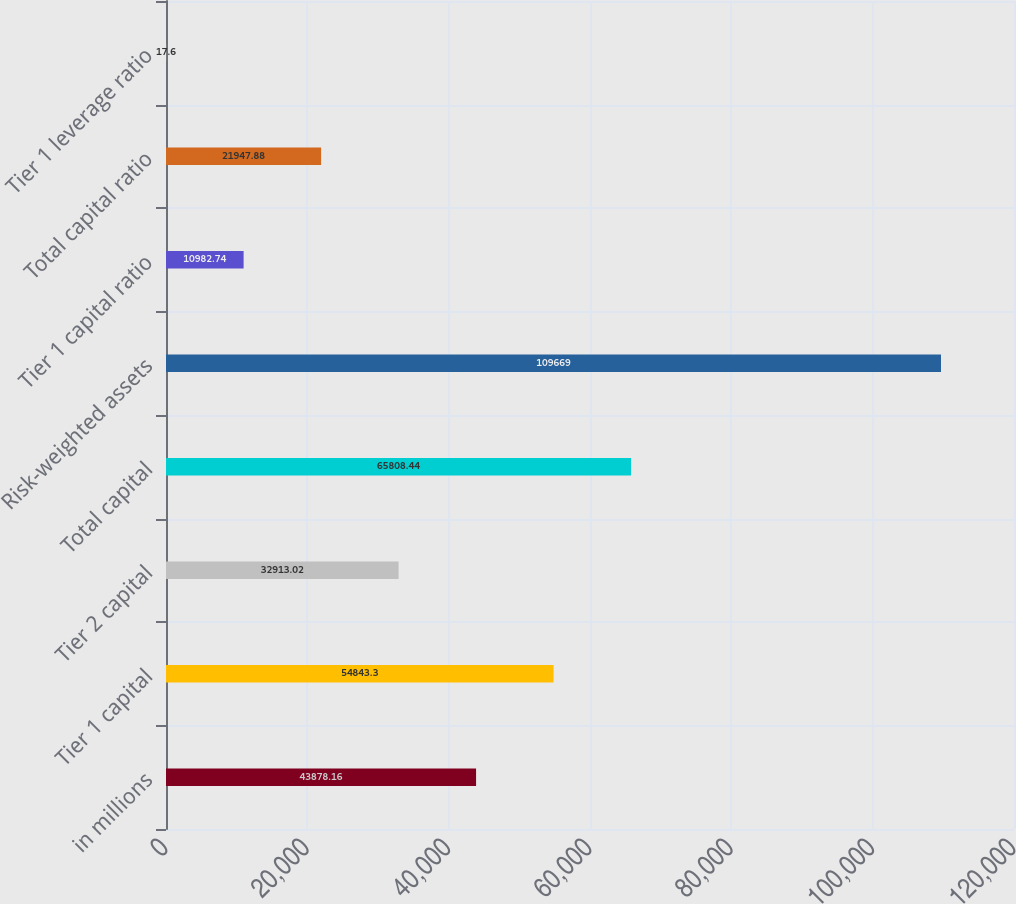Convert chart to OTSL. <chart><loc_0><loc_0><loc_500><loc_500><bar_chart><fcel>in millions<fcel>Tier 1 capital<fcel>Tier 2 capital<fcel>Total capital<fcel>Risk-weighted assets<fcel>Tier 1 capital ratio<fcel>Total capital ratio<fcel>Tier 1 leverage ratio<nl><fcel>43878.2<fcel>54843.3<fcel>32913<fcel>65808.4<fcel>109669<fcel>10982.7<fcel>21947.9<fcel>17.6<nl></chart> 